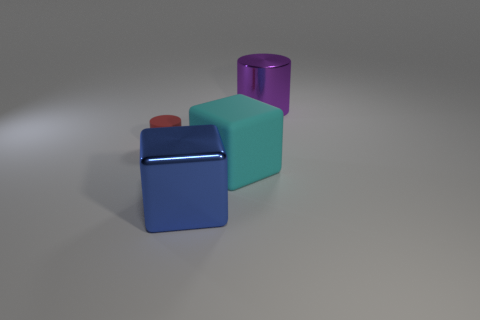Add 3 blue metal cylinders. How many objects exist? 7 Subtract 0 yellow cylinders. How many objects are left? 4 Subtract all big blue cubes. Subtract all large blue cylinders. How many objects are left? 3 Add 3 big blue shiny cubes. How many big blue shiny cubes are left? 4 Add 3 matte cylinders. How many matte cylinders exist? 4 